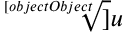Convert formula to latex. <formula><loc_0><loc_0><loc_500><loc_500>\sqrt { [ } [ o b j e c t O b j e c t ] ] { u }</formula> 